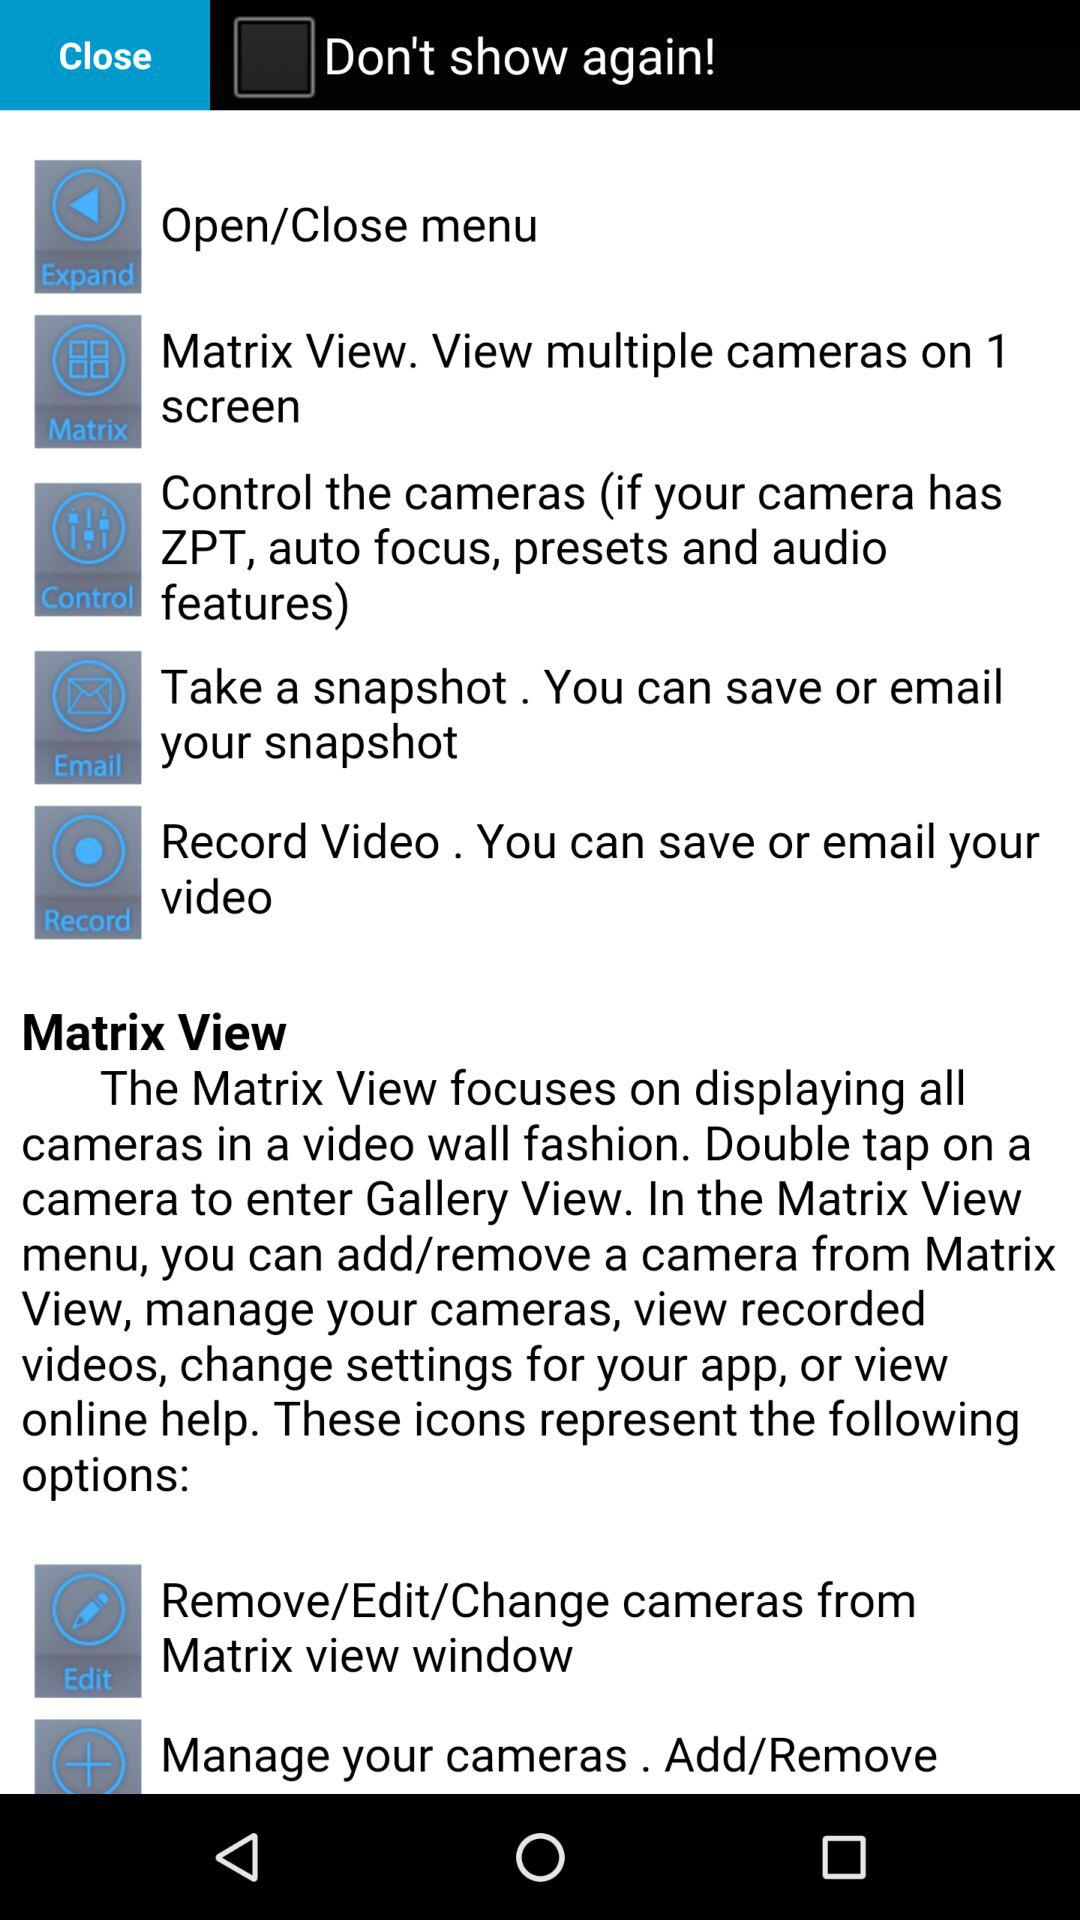What are the available options? The available options are "Close" and "Don't show again!". 